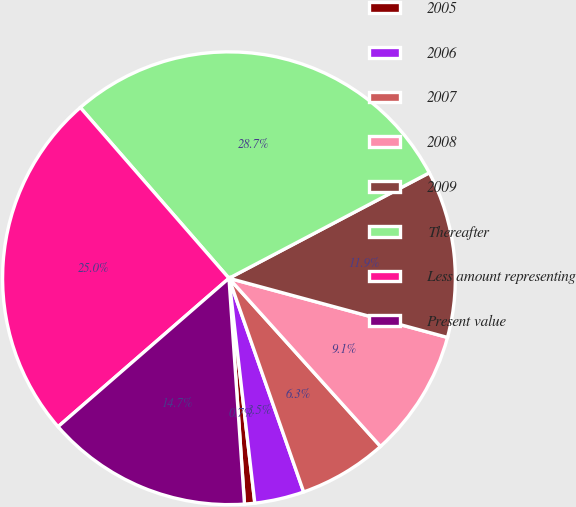Convert chart. <chart><loc_0><loc_0><loc_500><loc_500><pie_chart><fcel>2005<fcel>2006<fcel>2007<fcel>2008<fcel>2009<fcel>Thereafter<fcel>Less amount representing<fcel>Present value<nl><fcel>0.73%<fcel>3.53%<fcel>6.32%<fcel>9.12%<fcel>11.92%<fcel>28.69%<fcel>24.98%<fcel>14.71%<nl></chart> 